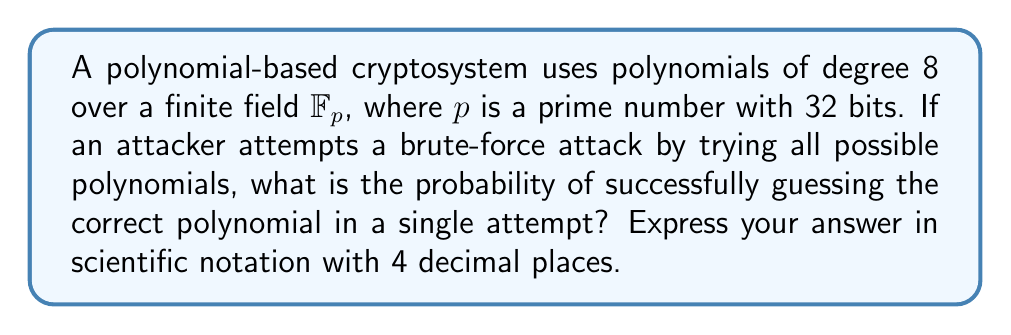Can you solve this math problem? To solve this problem, we need to follow these steps:

1. Determine the number of possible polynomials:
   - The polynomials are of degree 8 over $\mathbb{F}_p$
   - Each coefficient can be any element of $\mathbb{F}_p$
   - There are 9 coefficients (including the constant term)
   - The number of possible polynomials is $p^9$

2. Calculate the value of $p$:
   - $p$ is a prime number with 32 bits
   - The largest 32-bit number is $2^{32} - 1 = 4,294,967,295$
   - For simplicity, we'll use this as an approximation for $p$

3. Calculate the total number of possible polynomials:
   $$ \text{Total polynomials} = p^9 \approx (2^{32})^9 = 2^{288} $$

4. Calculate the probability of guessing the correct polynomial in one attempt:
   $$ \text{Probability} = \frac{1}{\text{Total polynomials}} = \frac{1}{2^{288}} $$

5. Convert the result to scientific notation:
   $$ \frac{1}{2^{288}} \approx 4.8568 \times 10^{-87} $$

This extremely low probability demonstrates why brute-force attacks on well-designed cryptosystems are computationally infeasible, contrary to some media portrayals that might suggest otherwise.
Answer: $4.8568 \times 10^{-87}$ 